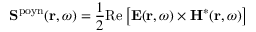Convert formula to latex. <formula><loc_0><loc_0><loc_500><loc_500>{ S } ^ { p o y n } ( { r } , \omega ) = \frac { 1 } { 2 } R e \left [ E ( { r } , \omega ) \times H ^ { * } ( { r } , \omega ) \right ]</formula> 